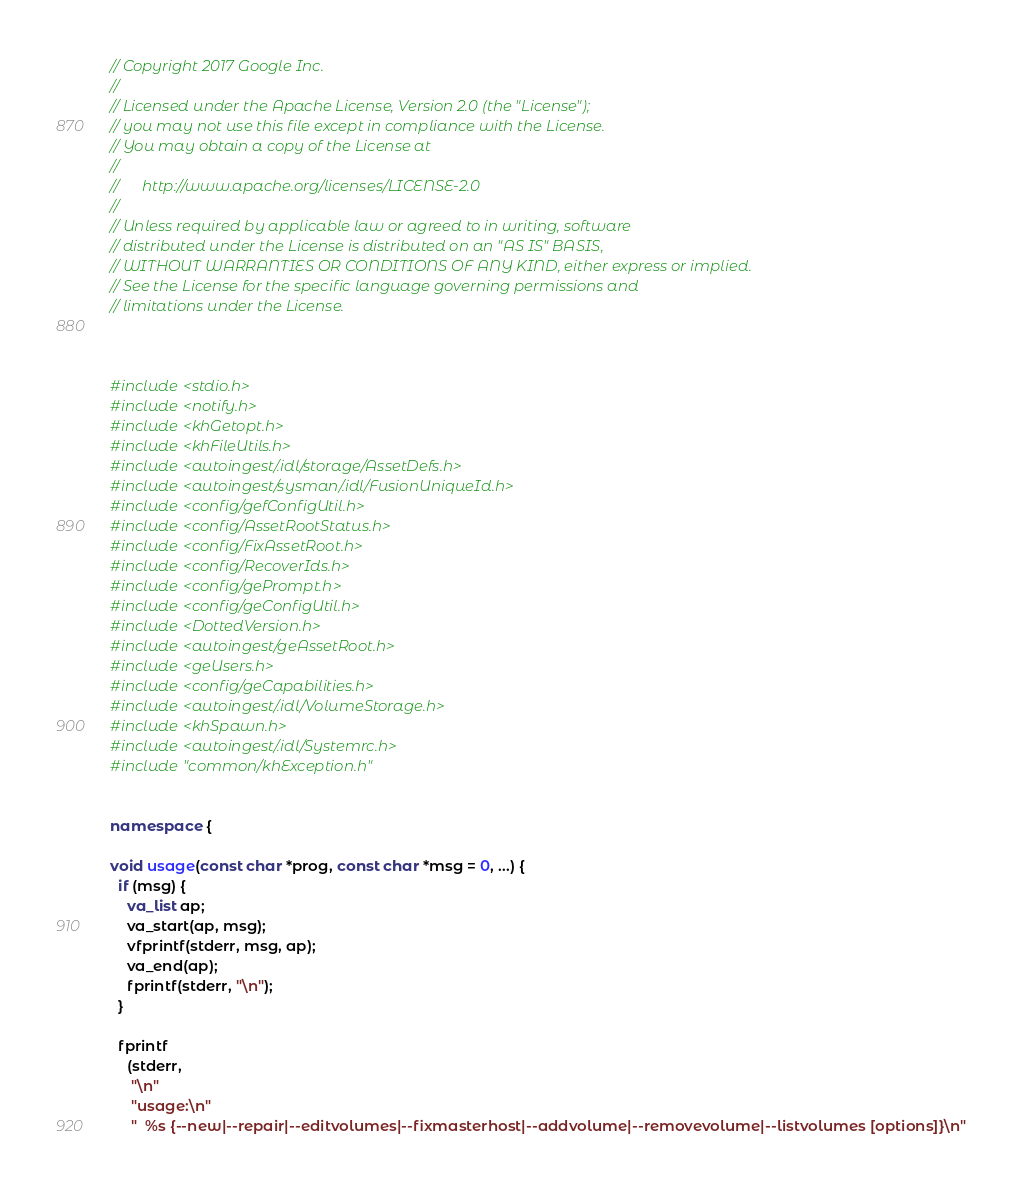<code> <loc_0><loc_0><loc_500><loc_500><_C++_>// Copyright 2017 Google Inc.
//
// Licensed under the Apache License, Version 2.0 (the "License");
// you may not use this file except in compliance with the License.
// You may obtain a copy of the License at
//
//      http://www.apache.org/licenses/LICENSE-2.0
//
// Unless required by applicable law or agreed to in writing, software
// distributed under the License is distributed on an "AS IS" BASIS,
// WITHOUT WARRANTIES OR CONDITIONS OF ANY KIND, either express or implied.
// See the License for the specific language governing permissions and
// limitations under the License.



#include <stdio.h>
#include <notify.h>
#include <khGetopt.h>
#include <khFileUtils.h>
#include <autoingest/.idl/storage/AssetDefs.h>
#include <autoingest/sysman/.idl/FusionUniqueId.h>
#include <config/gefConfigUtil.h>
#include <config/AssetRootStatus.h>
#include <config/FixAssetRoot.h>
#include <config/RecoverIds.h>
#include <config/gePrompt.h>
#include <config/geConfigUtil.h>
#include <DottedVersion.h>
#include <autoingest/geAssetRoot.h>
#include <geUsers.h>
#include <config/geCapabilities.h>
#include <autoingest/.idl/VolumeStorage.h>
#include <khSpawn.h>
#include <autoingest/.idl/Systemrc.h>
#include "common/khException.h"


namespace {

void usage(const char *prog, const char *msg = 0, ...) {
  if (msg) {
    va_list ap;
    va_start(ap, msg);
    vfprintf(stderr, msg, ap);
    va_end(ap);
    fprintf(stderr, "\n");
  }

  fprintf
    (stderr,
     "\n"
     "usage:\n"
     "  %s {--new|--repair|--editvolumes|--fixmasterhost|--addvolume|--removevolume|--listvolumes [options]}\n"</code> 